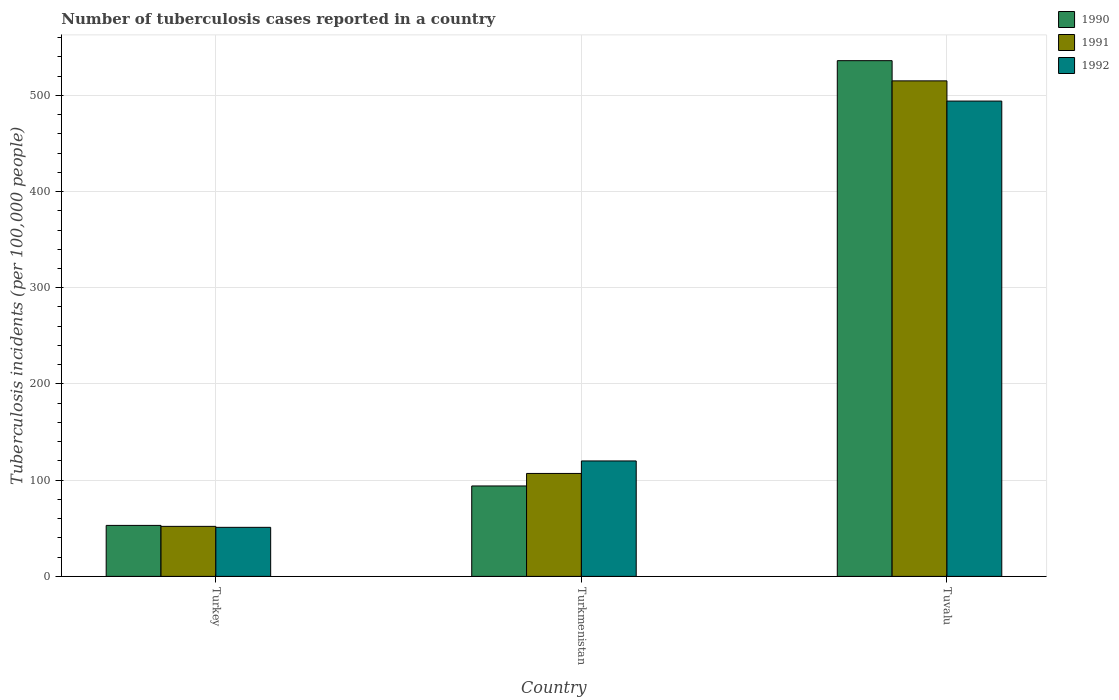How many different coloured bars are there?
Make the answer very short. 3. How many groups of bars are there?
Your answer should be very brief. 3. Are the number of bars on each tick of the X-axis equal?
Provide a succinct answer. Yes. What is the label of the 2nd group of bars from the left?
Your answer should be very brief. Turkmenistan. In how many cases, is the number of bars for a given country not equal to the number of legend labels?
Your answer should be compact. 0. What is the number of tuberculosis cases reported in in 1992 in Tuvalu?
Your response must be concise. 494. Across all countries, what is the maximum number of tuberculosis cases reported in in 1992?
Give a very brief answer. 494. In which country was the number of tuberculosis cases reported in in 1991 maximum?
Offer a terse response. Tuvalu. In which country was the number of tuberculosis cases reported in in 1992 minimum?
Offer a terse response. Turkey. What is the total number of tuberculosis cases reported in in 1992 in the graph?
Provide a succinct answer. 665. What is the difference between the number of tuberculosis cases reported in in 1991 in Turkey and that in Tuvalu?
Ensure brevity in your answer.  -463. What is the difference between the number of tuberculosis cases reported in in 1990 in Turkmenistan and the number of tuberculosis cases reported in in 1991 in Tuvalu?
Your answer should be very brief. -421. What is the average number of tuberculosis cases reported in in 1991 per country?
Your answer should be very brief. 224.67. What is the difference between the number of tuberculosis cases reported in of/in 1991 and number of tuberculosis cases reported in of/in 1990 in Tuvalu?
Ensure brevity in your answer.  -21. In how many countries, is the number of tuberculosis cases reported in in 1991 greater than 380?
Your response must be concise. 1. What is the ratio of the number of tuberculosis cases reported in in 1990 in Turkmenistan to that in Tuvalu?
Offer a terse response. 0.18. Is the number of tuberculosis cases reported in in 1990 in Turkey less than that in Turkmenistan?
Your answer should be very brief. Yes. Is the difference between the number of tuberculosis cases reported in in 1991 in Turkmenistan and Tuvalu greater than the difference between the number of tuberculosis cases reported in in 1990 in Turkmenistan and Tuvalu?
Your response must be concise. Yes. What is the difference between the highest and the lowest number of tuberculosis cases reported in in 1992?
Offer a terse response. 443. In how many countries, is the number of tuberculosis cases reported in in 1991 greater than the average number of tuberculosis cases reported in in 1991 taken over all countries?
Provide a succinct answer. 1. Is the sum of the number of tuberculosis cases reported in in 1992 in Turkey and Tuvalu greater than the maximum number of tuberculosis cases reported in in 1990 across all countries?
Your answer should be very brief. Yes. What does the 2nd bar from the left in Turkey represents?
Your response must be concise. 1991. How many bars are there?
Keep it short and to the point. 9. How many countries are there in the graph?
Provide a succinct answer. 3. Are the values on the major ticks of Y-axis written in scientific E-notation?
Your answer should be very brief. No. How are the legend labels stacked?
Provide a short and direct response. Vertical. What is the title of the graph?
Offer a very short reply. Number of tuberculosis cases reported in a country. What is the label or title of the Y-axis?
Offer a terse response. Tuberculosis incidents (per 100,0 people). What is the Tuberculosis incidents (per 100,000 people) of 1990 in Turkey?
Give a very brief answer. 53. What is the Tuberculosis incidents (per 100,000 people) in 1990 in Turkmenistan?
Offer a terse response. 94. What is the Tuberculosis incidents (per 100,000 people) in 1991 in Turkmenistan?
Provide a short and direct response. 107. What is the Tuberculosis incidents (per 100,000 people) in 1992 in Turkmenistan?
Make the answer very short. 120. What is the Tuberculosis incidents (per 100,000 people) of 1990 in Tuvalu?
Your answer should be very brief. 536. What is the Tuberculosis incidents (per 100,000 people) in 1991 in Tuvalu?
Provide a short and direct response. 515. What is the Tuberculosis incidents (per 100,000 people) in 1992 in Tuvalu?
Keep it short and to the point. 494. Across all countries, what is the maximum Tuberculosis incidents (per 100,000 people) of 1990?
Provide a succinct answer. 536. Across all countries, what is the maximum Tuberculosis incidents (per 100,000 people) in 1991?
Offer a very short reply. 515. Across all countries, what is the maximum Tuberculosis incidents (per 100,000 people) of 1992?
Provide a succinct answer. 494. Across all countries, what is the minimum Tuberculosis incidents (per 100,000 people) of 1990?
Your response must be concise. 53. Across all countries, what is the minimum Tuberculosis incidents (per 100,000 people) of 1991?
Provide a succinct answer. 52. What is the total Tuberculosis incidents (per 100,000 people) of 1990 in the graph?
Provide a short and direct response. 683. What is the total Tuberculosis incidents (per 100,000 people) of 1991 in the graph?
Offer a very short reply. 674. What is the total Tuberculosis incidents (per 100,000 people) in 1992 in the graph?
Your response must be concise. 665. What is the difference between the Tuberculosis incidents (per 100,000 people) of 1990 in Turkey and that in Turkmenistan?
Your answer should be very brief. -41. What is the difference between the Tuberculosis incidents (per 100,000 people) in 1991 in Turkey and that in Turkmenistan?
Offer a very short reply. -55. What is the difference between the Tuberculosis incidents (per 100,000 people) of 1992 in Turkey and that in Turkmenistan?
Give a very brief answer. -69. What is the difference between the Tuberculosis incidents (per 100,000 people) of 1990 in Turkey and that in Tuvalu?
Provide a succinct answer. -483. What is the difference between the Tuberculosis incidents (per 100,000 people) of 1991 in Turkey and that in Tuvalu?
Your response must be concise. -463. What is the difference between the Tuberculosis incidents (per 100,000 people) of 1992 in Turkey and that in Tuvalu?
Offer a terse response. -443. What is the difference between the Tuberculosis incidents (per 100,000 people) of 1990 in Turkmenistan and that in Tuvalu?
Offer a very short reply. -442. What is the difference between the Tuberculosis incidents (per 100,000 people) in 1991 in Turkmenistan and that in Tuvalu?
Your response must be concise. -408. What is the difference between the Tuberculosis incidents (per 100,000 people) in 1992 in Turkmenistan and that in Tuvalu?
Your response must be concise. -374. What is the difference between the Tuberculosis incidents (per 100,000 people) in 1990 in Turkey and the Tuberculosis incidents (per 100,000 people) in 1991 in Turkmenistan?
Provide a short and direct response. -54. What is the difference between the Tuberculosis incidents (per 100,000 people) in 1990 in Turkey and the Tuberculosis incidents (per 100,000 people) in 1992 in Turkmenistan?
Offer a very short reply. -67. What is the difference between the Tuberculosis incidents (per 100,000 people) of 1991 in Turkey and the Tuberculosis incidents (per 100,000 people) of 1992 in Turkmenistan?
Offer a very short reply. -68. What is the difference between the Tuberculosis incidents (per 100,000 people) of 1990 in Turkey and the Tuberculosis incidents (per 100,000 people) of 1991 in Tuvalu?
Provide a short and direct response. -462. What is the difference between the Tuberculosis incidents (per 100,000 people) of 1990 in Turkey and the Tuberculosis incidents (per 100,000 people) of 1992 in Tuvalu?
Keep it short and to the point. -441. What is the difference between the Tuberculosis incidents (per 100,000 people) in 1991 in Turkey and the Tuberculosis incidents (per 100,000 people) in 1992 in Tuvalu?
Offer a terse response. -442. What is the difference between the Tuberculosis incidents (per 100,000 people) in 1990 in Turkmenistan and the Tuberculosis incidents (per 100,000 people) in 1991 in Tuvalu?
Offer a very short reply. -421. What is the difference between the Tuberculosis incidents (per 100,000 people) of 1990 in Turkmenistan and the Tuberculosis incidents (per 100,000 people) of 1992 in Tuvalu?
Offer a terse response. -400. What is the difference between the Tuberculosis incidents (per 100,000 people) of 1991 in Turkmenistan and the Tuberculosis incidents (per 100,000 people) of 1992 in Tuvalu?
Your answer should be very brief. -387. What is the average Tuberculosis incidents (per 100,000 people) in 1990 per country?
Make the answer very short. 227.67. What is the average Tuberculosis incidents (per 100,000 people) in 1991 per country?
Offer a very short reply. 224.67. What is the average Tuberculosis incidents (per 100,000 people) in 1992 per country?
Offer a terse response. 221.67. What is the difference between the Tuberculosis incidents (per 100,000 people) of 1990 and Tuberculosis incidents (per 100,000 people) of 1992 in Turkey?
Provide a short and direct response. 2. What is the difference between the Tuberculosis incidents (per 100,000 people) of 1990 and Tuberculosis incidents (per 100,000 people) of 1991 in Tuvalu?
Your answer should be very brief. 21. What is the difference between the Tuberculosis incidents (per 100,000 people) in 1990 and Tuberculosis incidents (per 100,000 people) in 1992 in Tuvalu?
Provide a succinct answer. 42. What is the ratio of the Tuberculosis incidents (per 100,000 people) in 1990 in Turkey to that in Turkmenistan?
Your answer should be compact. 0.56. What is the ratio of the Tuberculosis incidents (per 100,000 people) of 1991 in Turkey to that in Turkmenistan?
Offer a very short reply. 0.49. What is the ratio of the Tuberculosis incidents (per 100,000 people) in 1992 in Turkey to that in Turkmenistan?
Ensure brevity in your answer.  0.42. What is the ratio of the Tuberculosis incidents (per 100,000 people) in 1990 in Turkey to that in Tuvalu?
Keep it short and to the point. 0.1. What is the ratio of the Tuberculosis incidents (per 100,000 people) of 1991 in Turkey to that in Tuvalu?
Provide a short and direct response. 0.1. What is the ratio of the Tuberculosis incidents (per 100,000 people) of 1992 in Turkey to that in Tuvalu?
Provide a succinct answer. 0.1. What is the ratio of the Tuberculosis incidents (per 100,000 people) in 1990 in Turkmenistan to that in Tuvalu?
Your answer should be very brief. 0.18. What is the ratio of the Tuberculosis incidents (per 100,000 people) of 1991 in Turkmenistan to that in Tuvalu?
Make the answer very short. 0.21. What is the ratio of the Tuberculosis incidents (per 100,000 people) of 1992 in Turkmenistan to that in Tuvalu?
Keep it short and to the point. 0.24. What is the difference between the highest and the second highest Tuberculosis incidents (per 100,000 people) of 1990?
Offer a very short reply. 442. What is the difference between the highest and the second highest Tuberculosis incidents (per 100,000 people) of 1991?
Give a very brief answer. 408. What is the difference between the highest and the second highest Tuberculosis incidents (per 100,000 people) in 1992?
Your answer should be compact. 374. What is the difference between the highest and the lowest Tuberculosis incidents (per 100,000 people) of 1990?
Ensure brevity in your answer.  483. What is the difference between the highest and the lowest Tuberculosis incidents (per 100,000 people) in 1991?
Your response must be concise. 463. What is the difference between the highest and the lowest Tuberculosis incidents (per 100,000 people) in 1992?
Provide a succinct answer. 443. 